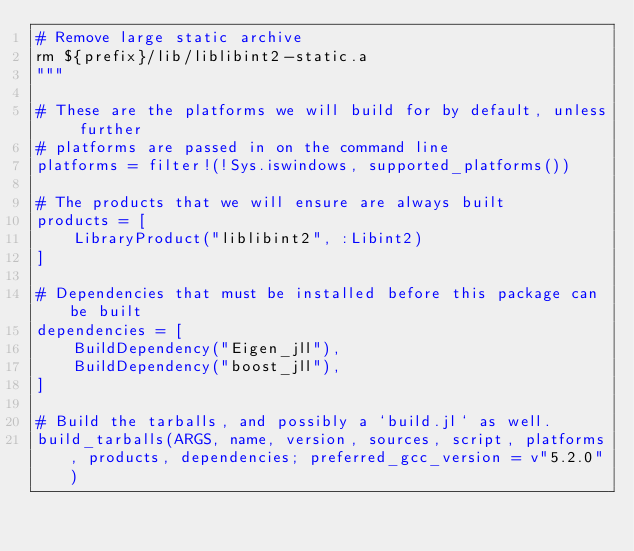<code> <loc_0><loc_0><loc_500><loc_500><_Julia_># Remove large static archive
rm ${prefix}/lib/liblibint2-static.a
"""

# These are the platforms we will build for by default, unless further
# platforms are passed in on the command line
platforms = filter!(!Sys.iswindows, supported_platforms())

# The products that we will ensure are always built
products = [
    LibraryProduct("liblibint2", :Libint2)
]

# Dependencies that must be installed before this package can be built
dependencies = [
    BuildDependency("Eigen_jll"),
    BuildDependency("boost_jll"),
]

# Build the tarballs, and possibly a `build.jl` as well.
build_tarballs(ARGS, name, version, sources, script, platforms, products, dependencies; preferred_gcc_version = v"5.2.0")
</code> 